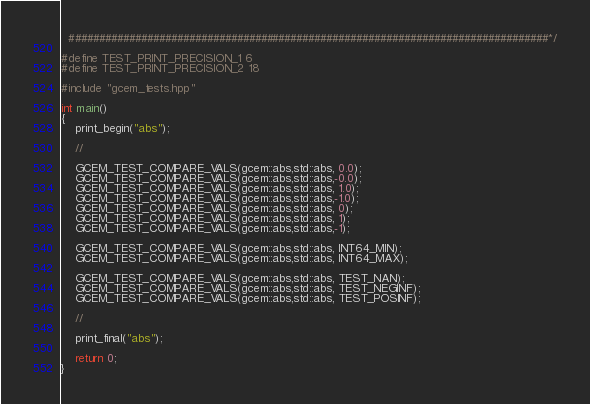Convert code to text. <code><loc_0><loc_0><loc_500><loc_500><_C++_>  ################################################################################*/

#define TEST_PRINT_PRECISION_1 6
#define TEST_PRINT_PRECISION_2 18

#include "gcem_tests.hpp"

int main()
{
    print_begin("abs");

    //

    GCEM_TEST_COMPARE_VALS(gcem::abs,std::abs, 0.0);
    GCEM_TEST_COMPARE_VALS(gcem::abs,std::abs,-0.0);
    GCEM_TEST_COMPARE_VALS(gcem::abs,std::abs, 1.0);
    GCEM_TEST_COMPARE_VALS(gcem::abs,std::abs,-1.0);
    GCEM_TEST_COMPARE_VALS(gcem::abs,std::abs, 0);
    GCEM_TEST_COMPARE_VALS(gcem::abs,std::abs, 1);
    GCEM_TEST_COMPARE_VALS(gcem::abs,std::abs,-1);

    GCEM_TEST_COMPARE_VALS(gcem::abs,std::abs, INT64_MIN);
    GCEM_TEST_COMPARE_VALS(gcem::abs,std::abs, INT64_MAX);

    GCEM_TEST_COMPARE_VALS(gcem::abs,std::abs, TEST_NAN);
    GCEM_TEST_COMPARE_VALS(gcem::abs,std::abs, TEST_NEGINF);
    GCEM_TEST_COMPARE_VALS(gcem::abs,std::abs, TEST_POSINF);

    //

    print_final("abs");

    return 0;
}
</code> 